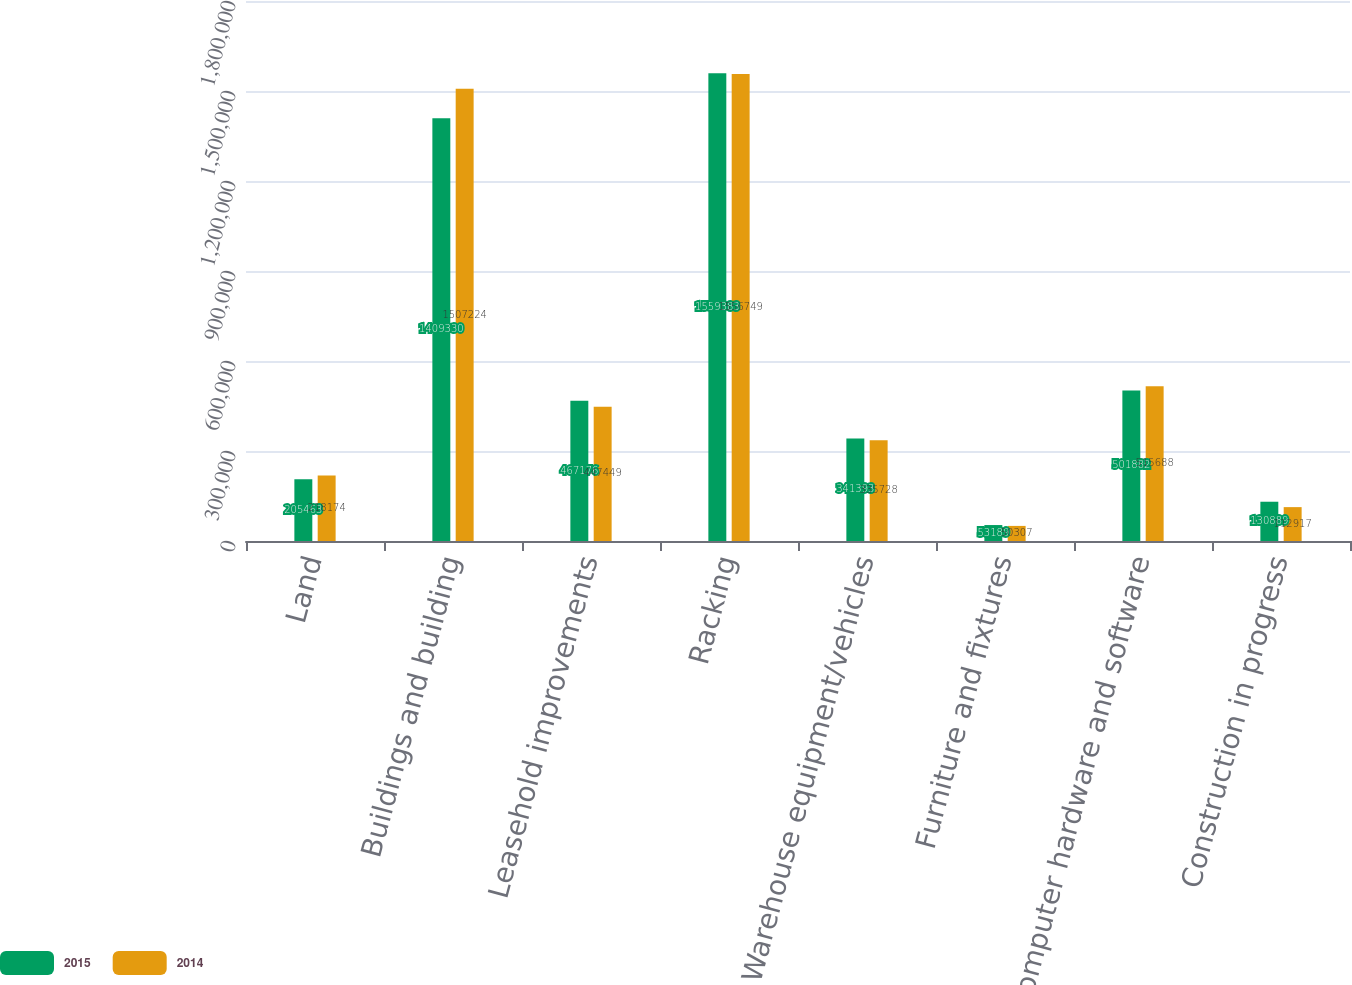<chart> <loc_0><loc_0><loc_500><loc_500><stacked_bar_chart><ecel><fcel>Land<fcel>Buildings and building<fcel>Leasehold improvements<fcel>Racking<fcel>Warehouse equipment/vehicles<fcel>Furniture and fixtures<fcel>Computer hardware and software<fcel>Construction in progress<nl><fcel>2015<fcel>205463<fcel>1.40933e+06<fcel>467176<fcel>1.55938e+06<fcel>341393<fcel>53189<fcel>501882<fcel>130889<nl><fcel>2014<fcel>218174<fcel>1.50722e+06<fcel>447449<fcel>1.55675e+06<fcel>335728<fcel>50307<fcel>515688<fcel>112917<nl></chart> 